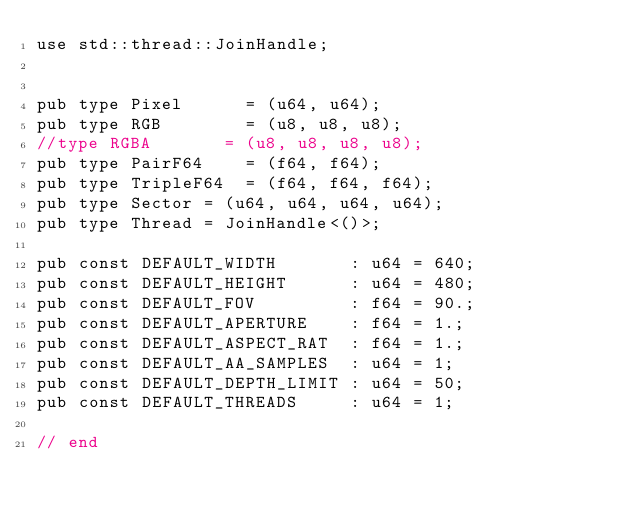Convert code to text. <code><loc_0><loc_0><loc_500><loc_500><_Rust_>use std::thread::JoinHandle;


pub type Pixel      = (u64, u64);
pub type RGB        = (u8, u8, u8);
//type RGBA       = (u8, u8, u8, u8);
pub type PairF64    = (f64, f64);
pub type TripleF64  = (f64, f64, f64);
pub type Sector = (u64, u64, u64, u64);
pub type Thread = JoinHandle<()>;

pub const DEFAULT_WIDTH       : u64 = 640;
pub const DEFAULT_HEIGHT      : u64 = 480;
pub const DEFAULT_FOV         : f64 = 90.;
pub const DEFAULT_APERTURE    : f64 = 1.;
pub const DEFAULT_ASPECT_RAT  : f64 = 1.;
pub const DEFAULT_AA_SAMPLES  : u64 = 1;
pub const DEFAULT_DEPTH_LIMIT : u64 = 50;
pub const DEFAULT_THREADS     : u64 = 1;

// end
</code> 